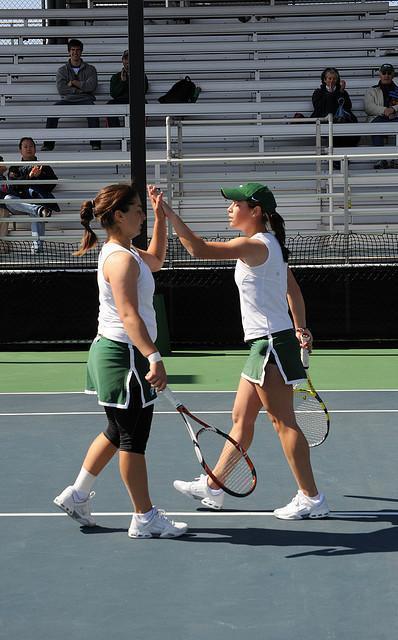How many people can be seen?
Give a very brief answer. 4. 